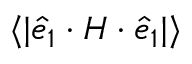<formula> <loc_0><loc_0><loc_500><loc_500>\langle | \hat { e } _ { 1 } \cdot H \cdot \hat { e } _ { 1 } | \rangle</formula> 